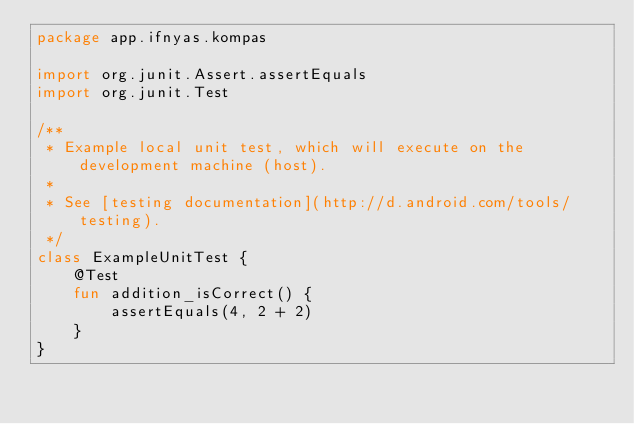<code> <loc_0><loc_0><loc_500><loc_500><_Kotlin_>package app.ifnyas.kompas

import org.junit.Assert.assertEquals
import org.junit.Test

/**
 * Example local unit test, which will execute on the development machine (host).
 *
 * See [testing documentation](http://d.android.com/tools/testing).
 */
class ExampleUnitTest {
    @Test
    fun addition_isCorrect() {
        assertEquals(4, 2 + 2)
    }
}</code> 